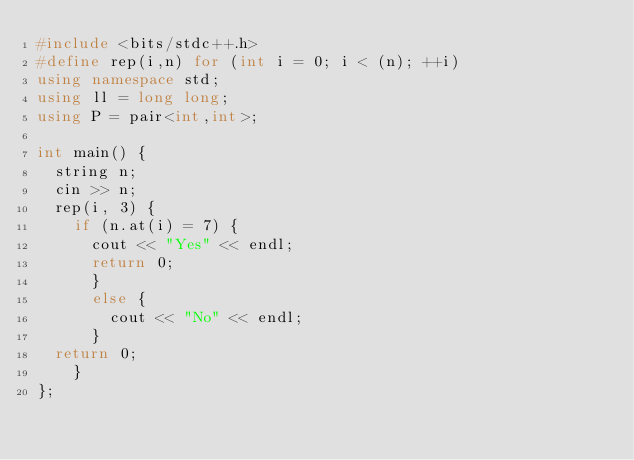Convert code to text. <code><loc_0><loc_0><loc_500><loc_500><_C++_>#include <bits/stdc++.h>
#define rep(i,n) for (int i = 0; i < (n); ++i)
using namespace std;
using ll = long long;
using P = pair<int,int>;

int main() {
  string n;
  cin >> n;
  rep(i, 3) {
    if (n.at(i) = 7) {
      cout << "Yes" << endl;
      return 0;
      }
      else {
        cout << "No" << endl;
      }
  return 0;
    } 
};</code> 